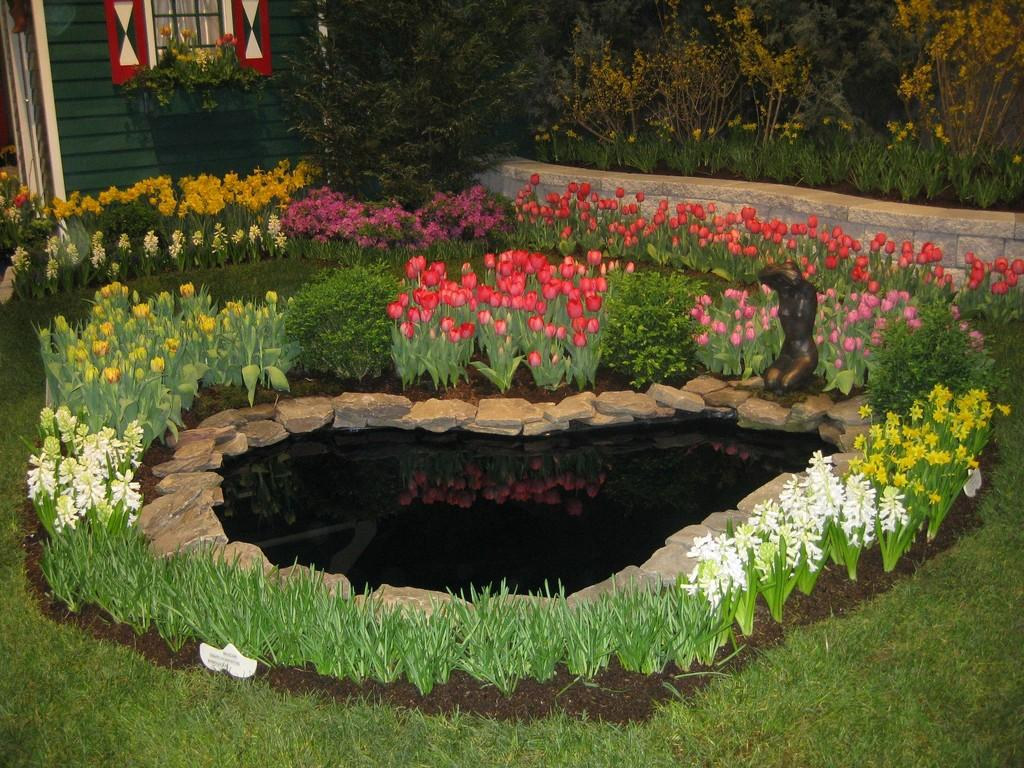What type of water body is present in the image? There is a pond in the image. What other natural elements can be seen in the image? There are rocks and plants with different flowers in the image. What type of vegetation is present on the ground in the image? There is grass on the floor in the image. What type of structure is located on the left side of the image? There is a building on the left side of the image. What feature of the building is visible in the image? The building has a window. What type of yam is being used to make juice in the image? There is no yam or juice present in the image. What type of linen is draped over the plants in the image? There is no linen present in the image; the plants are not covered or draped. 